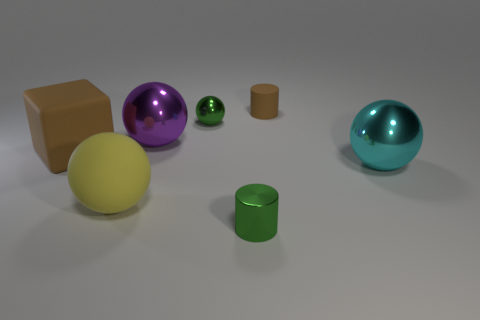There is a cube; are there any big yellow spheres in front of it?
Your response must be concise. Yes. There is a cylinder that is the same color as the cube; what is its material?
Ensure brevity in your answer.  Rubber. What number of cubes are either big purple shiny objects or large yellow matte objects?
Provide a succinct answer. 0. Do the big yellow thing and the large cyan metal object have the same shape?
Offer a terse response. Yes. There is a brown rubber object on the left side of the small sphere; what size is it?
Your answer should be compact. Large. Are there any blocks of the same color as the shiny cylinder?
Provide a succinct answer. No. Does the brown thing in front of the matte cylinder have the same size as the cyan thing?
Your response must be concise. Yes. The tiny metal sphere is what color?
Ensure brevity in your answer.  Green. There is a big ball that is in front of the big shiny thing that is in front of the big brown cube; what is its color?
Your answer should be very brief. Yellow. Are there any big balls that have the same material as the big brown thing?
Your answer should be very brief. Yes. 